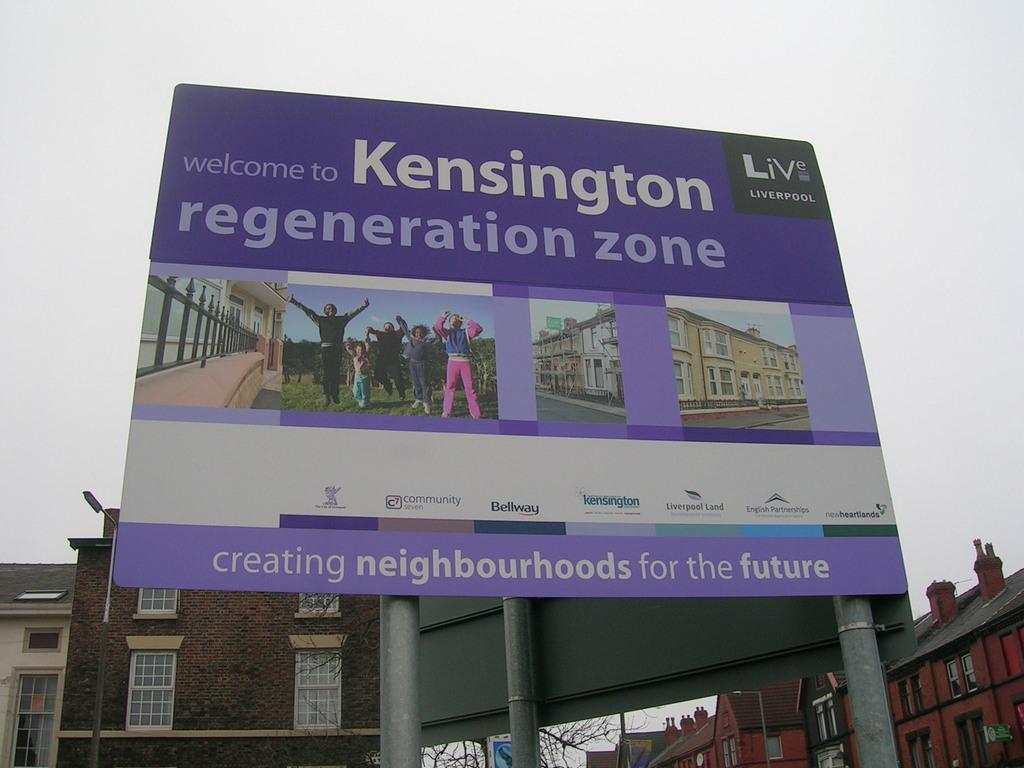What organization put this sign up?
Keep it short and to the point. Kensington. 